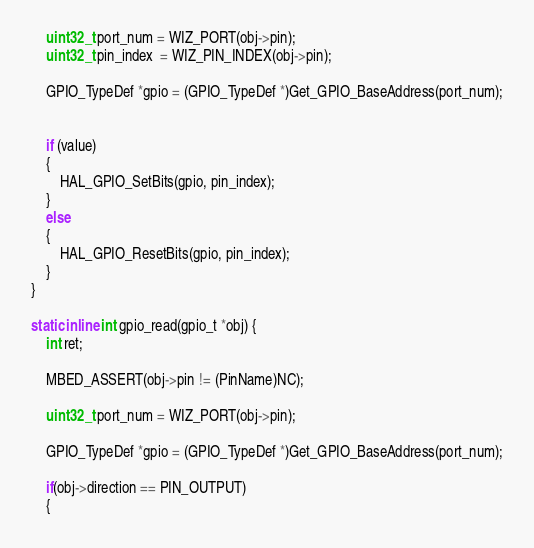Convert code to text. <code><loc_0><loc_0><loc_500><loc_500><_C_>
    uint32_t port_num = WIZ_PORT(obj->pin);
    uint32_t pin_index  = WIZ_PIN_INDEX(obj->pin);

    GPIO_TypeDef *gpio = (GPIO_TypeDef *)Get_GPIO_BaseAddress(port_num);
    

    if (value)
    {
        HAL_GPIO_SetBits(gpio, pin_index);
    }
    else
    {
        HAL_GPIO_ResetBits(gpio, pin_index);
    }
}

static inline int gpio_read(gpio_t *obj) {
    int ret;

    MBED_ASSERT(obj->pin != (PinName)NC);

    uint32_t port_num = WIZ_PORT(obj->pin);

    GPIO_TypeDef *gpio = (GPIO_TypeDef *)Get_GPIO_BaseAddress(port_num);

    if(obj->direction == PIN_OUTPUT)
    {</code> 